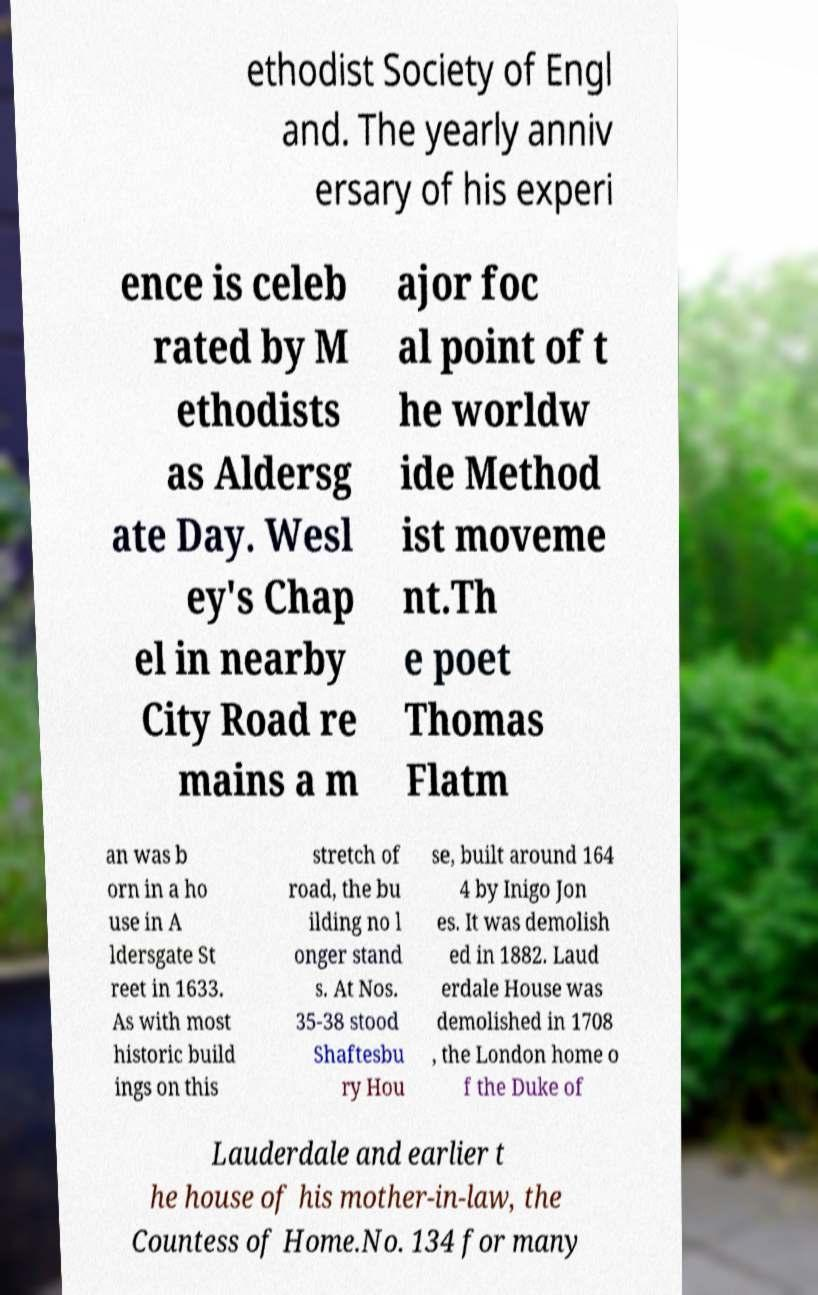There's text embedded in this image that I need extracted. Can you transcribe it verbatim? ethodist Society of Engl and. The yearly anniv ersary of his experi ence is celeb rated by M ethodists as Aldersg ate Day. Wesl ey's Chap el in nearby City Road re mains a m ajor foc al point of t he worldw ide Method ist moveme nt.Th e poet Thomas Flatm an was b orn in a ho use in A ldersgate St reet in 1633. As with most historic build ings on this stretch of road, the bu ilding no l onger stand s. At Nos. 35-38 stood Shaftesbu ry Hou se, built around 164 4 by Inigo Jon es. It was demolish ed in 1882. Laud erdale House was demolished in 1708 , the London home o f the Duke of Lauderdale and earlier t he house of his mother-in-law, the Countess of Home.No. 134 for many 